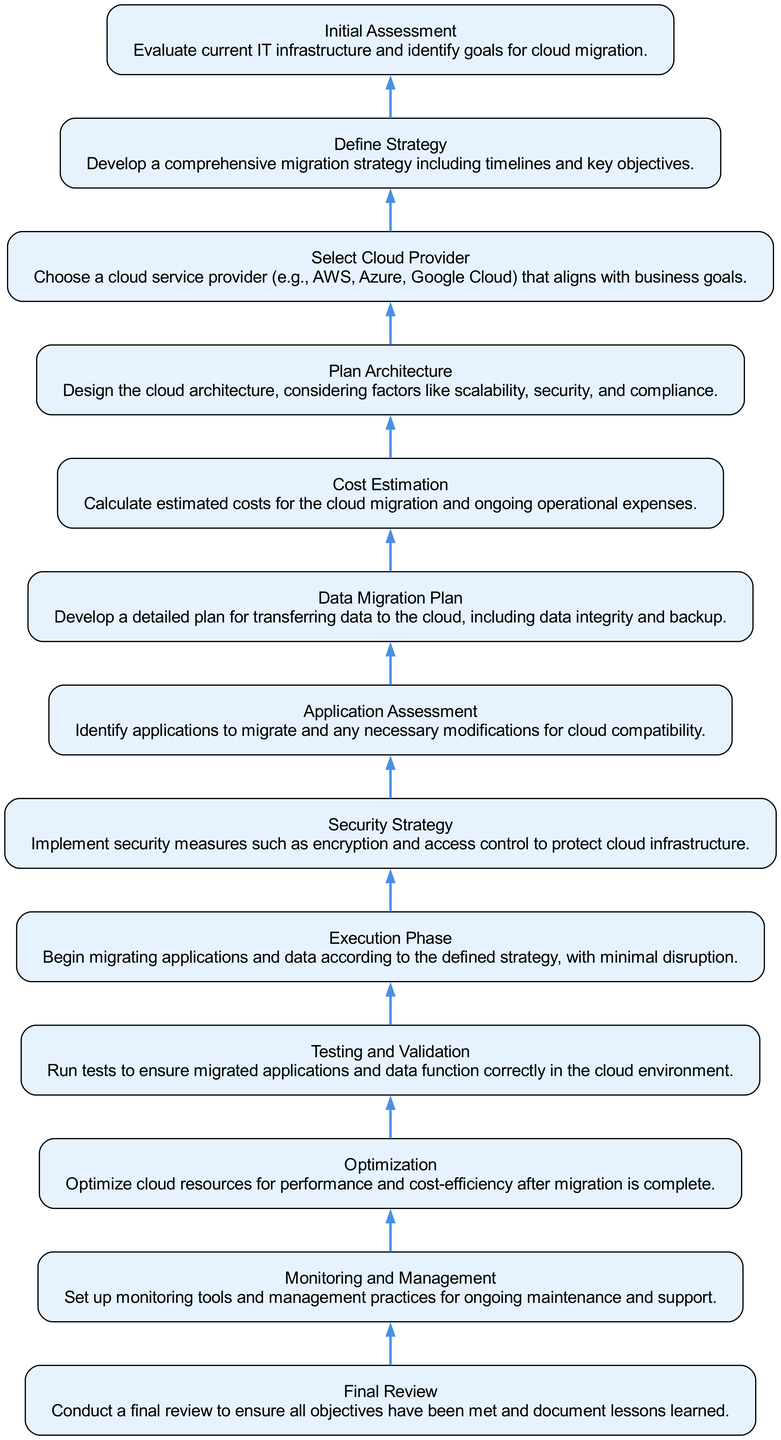What is the first step in the migration process? The first step listed in the diagram is "Initial Assessment," which involves evaluating the current IT infrastructure and identifying goals for cloud migration.
Answer: Initial Assessment How many total steps are there in the process? The diagram includes 13 distinct nodes, each representing a step in the cloud migration process.
Answer: 13 What step comes after "Cost Estimation"? The next step after "Cost Estimation" is "Data Migration Plan," which focuses on developing a plan for transferring data to the cloud.
Answer: Data Migration Plan What is the last step in the process? The final step in the migration process is "Final Review," which involves ensuring all objectives have been met and documenting lessons learned.
Answer: Final Review Which step emphasizes security measures? The "Security Strategy" step highlights the importance of implementing security measures such as encryption and access control for the cloud infrastructure.
Answer: Security Strategy What is the relationship between "Select Cloud Provider" and "Define Strategy"? "Select Cloud Provider" is dependent on "Define Strategy" because choosing a provider that aligns with the migration strategy is crucial to accomplishing the overall goals.
Answer: Select Cloud Provider is dependent on Define Strategy How does "Optimization" relate to "Testing and Validation"? "Optimization" happens after "Testing and Validation"; once applications and data are tested and validated, they can be optimized for performance and cost-efficiency.
Answer: Optimization follows Testing and Validation In which step is the cloud architecture designed? The "Plan Architecture" step is where the cloud architecture is designed, taking into account factors like scalability and compliance.
Answer: Plan Architecture What step discusses identifying applications to migrate? The step called "Application Assessment" focuses on identifying the applications that need to be migrated and any necessary modifications for cloud compatibility.
Answer: Application Assessment 